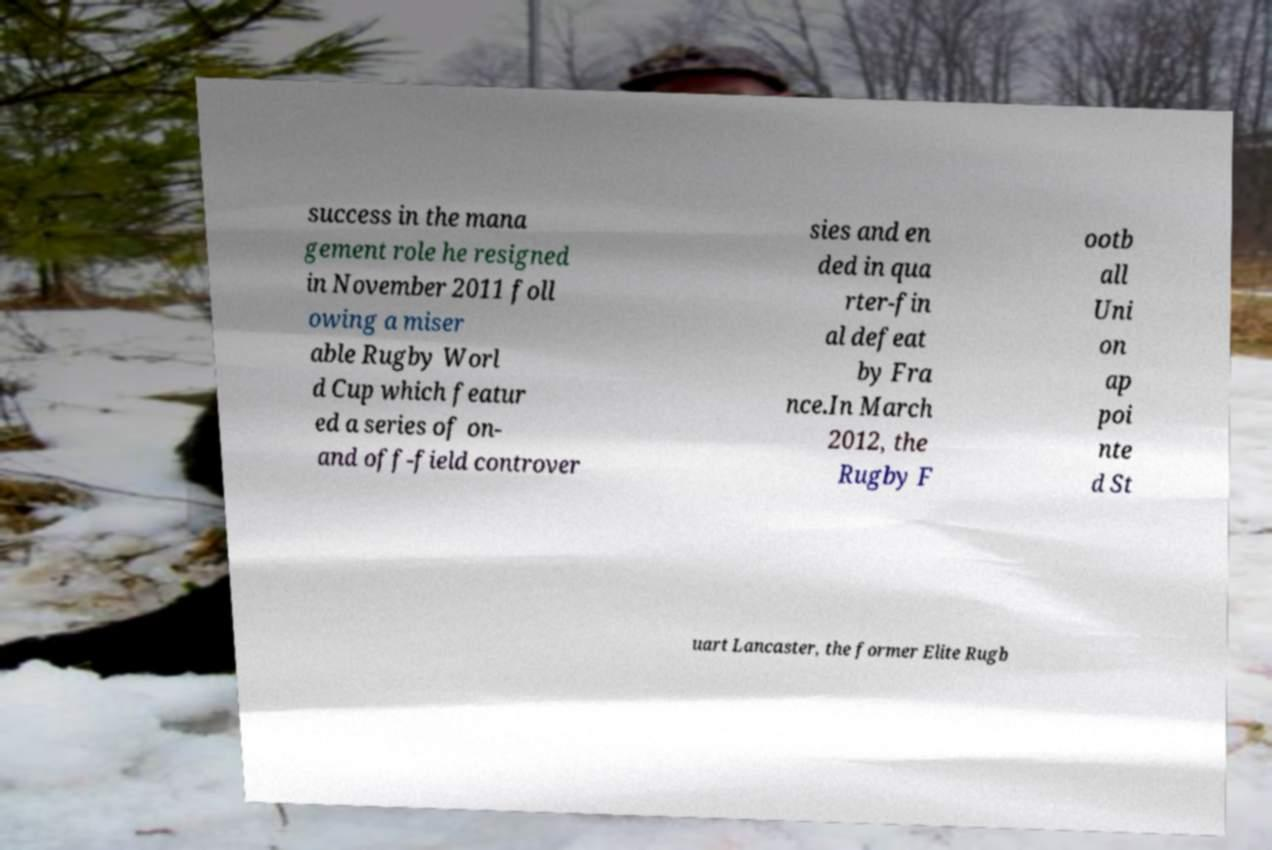Can you read and provide the text displayed in the image?This photo seems to have some interesting text. Can you extract and type it out for me? success in the mana gement role he resigned in November 2011 foll owing a miser able Rugby Worl d Cup which featur ed a series of on- and off-field controver sies and en ded in qua rter-fin al defeat by Fra nce.In March 2012, the Rugby F ootb all Uni on ap poi nte d St uart Lancaster, the former Elite Rugb 